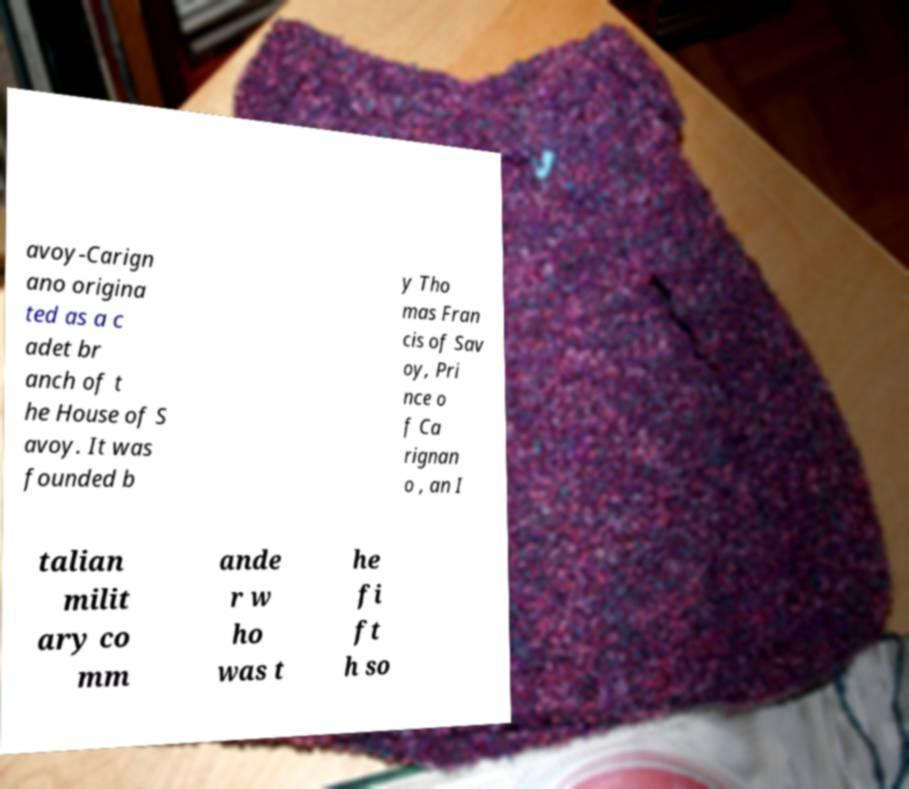Can you read and provide the text displayed in the image?This photo seems to have some interesting text. Can you extract and type it out for me? avoy-Carign ano origina ted as a c adet br anch of t he House of S avoy. It was founded b y Tho mas Fran cis of Sav oy, Pri nce o f Ca rignan o , an I talian milit ary co mm ande r w ho was t he fi ft h so 